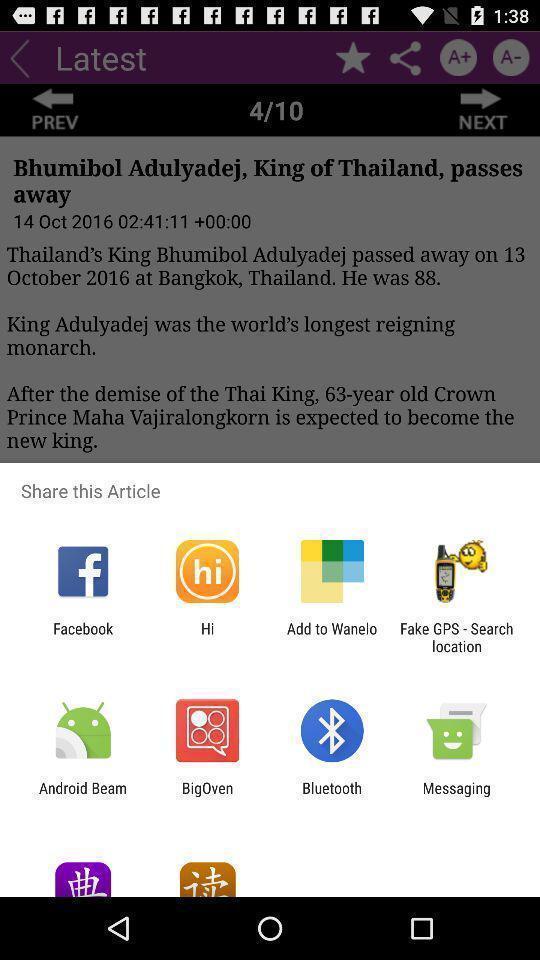Describe the key features of this screenshot. Pop-up shows share article with multiple applications. 